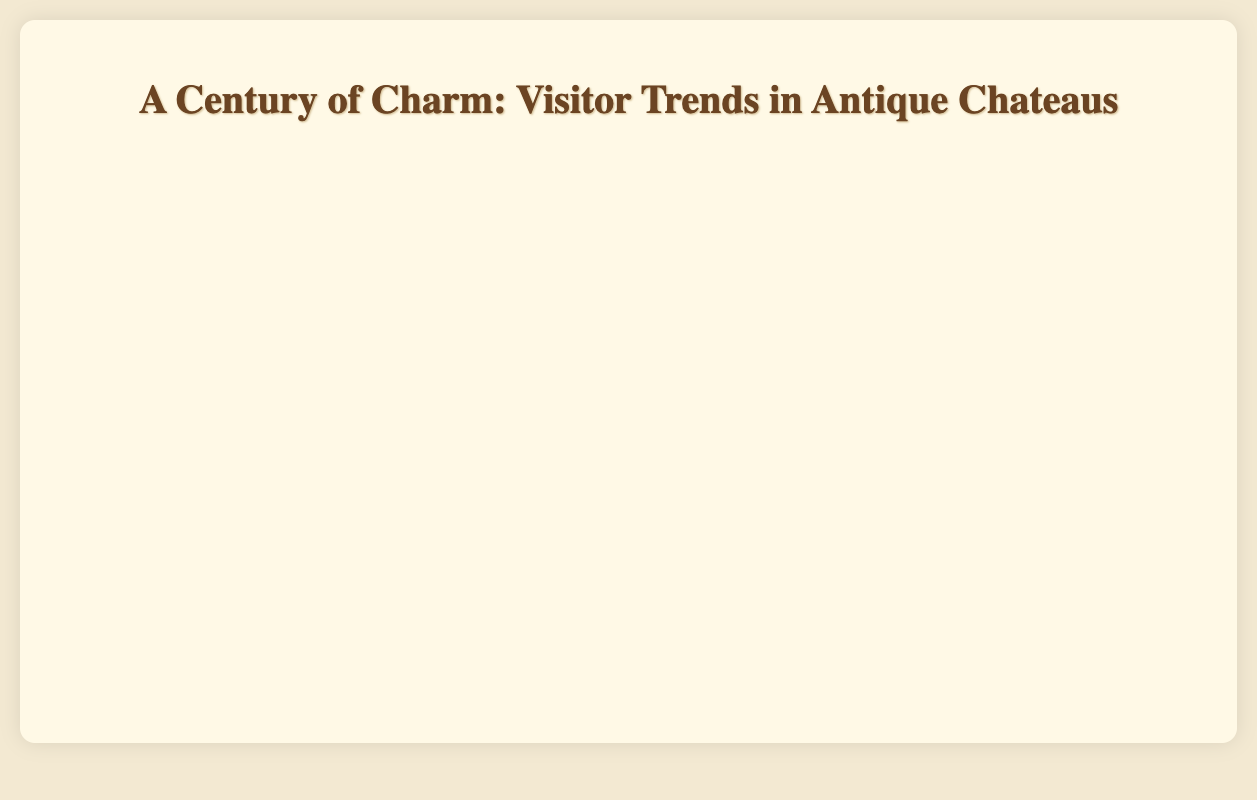What is the general trend in the number of summer visitors to Chateau de Chambord from 1923 to 2023? The line for Chateau de Chambord shows a general upward trend in summer visitors from 1923 to 2023. Starting from 2500 visitors in 1923 and increasing gradually to 3800 visitors in 2023 in a mostly consistent manner.
Answer: Gradual increase How do the number of winter visitors to Chateau de Versailles in 2023 compare to those in 1923? In 1923, Chateau de Versailles had 2000 winter visitors. In 2023, this number increased to 2900, indicating a difference of 900 more winter visitors in 2023 compared to 1923.
Answer: 900 more Which chateau had the highest number of summer visitors in 2023 and how many were there? By comparing the highest peaks of the lines in 2023, Chateau de Versailles had the highest number of summer visitors with 7600 visitors.
Answer: Chateau de Versailles with 7600 visitors Compare the number of summer visitors to Chateau de Fontainebleau and Chateau de Chantilly in 1943. In 1943, Chateau de Fontainebleau had 1900 summer visitors, while Chateau de Chantilly had 1100 summer visitors. Thus, Chateau de Fontainebleau had 800 more summer visitors than Chateau de Chantilly.
Answer: Chateau de Fontainebleau has 800 more Which season generally has the lowest number of visitors across all chateaus from 1923 to 2023? For each chateau, winter generally has the lowest number of visitors compared to other seasons throughout the years.
Answer: Winter What is the difference between summer visitors to Chateau de Chenonceau and Chateau de Fontainebleau in 2023? In 2023, Chateau de Chenonceau had 4600 summer visitors, while Chateau de Fontainebleau had 3000. The difference is 4600 - 3000 = 1600 visitors.
Answer: 1600 Which chateau had a consistent increase in summer visitors from 1923 to 2023? Chateau de Versailles had a consistent and steady increase in summer visitors each recorded year from 1923 to 2023.
Answer: Chateau de Versailles How does the number of spring visitors to Chateau de Chambord in 1953 compare to Chateau de Chenonceau in the same year? In 1953, Chateau de Chambord had 1700 spring visitors, and Chateau de Chenonceau had 2200 spring visitors. Chateau de Chenonceau had 500 more spring visitors than Chateau de Chambord.
Answer: 500 more Calculate the average number of summer visitors for Chateau de Versailles over the entire period. The summer visitor numbers for Chateau de Versailles over the years are 6000, 6200, 5900, 6300, 6500, 6700, 6800, 7000, 7200, 7400, 7600. Sum is 73600, and there are 11 years, so the average is 73600/11 = 6681.82.
Answer: 6681.82 